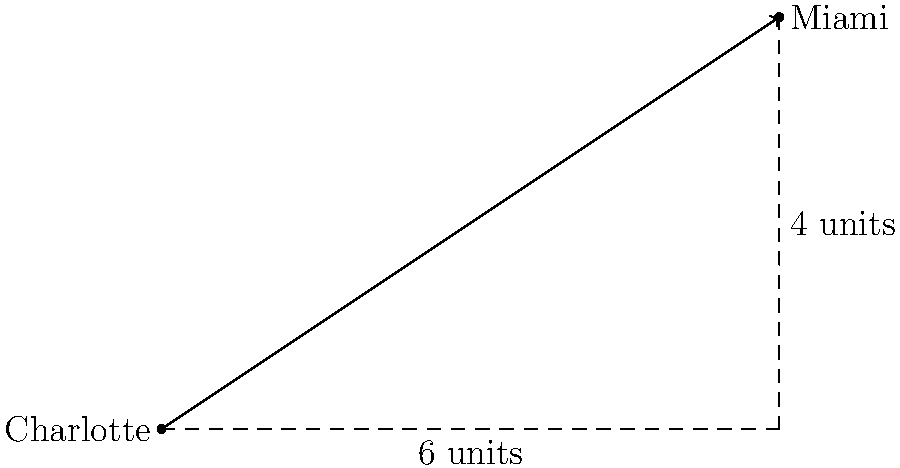As a proud North Carolinian and NBA enthusiast, you're planning a road trip to watch the Charlotte Hornets play an away game against the Miami Heat. On your map, Charlotte is represented at the origin (0,0), and Miami is located 6 units east and 4 units north. Using vector calculations, determine the direct distance between these two NBA cities. Let's approach this step-by-step using our God-given common sense and some basic math:

1) First, we need to understand that the vector from Charlotte to Miami can be represented as $\vec{v} = (6, 4)$.

2) To find the distance, we need to calculate the magnitude (length) of this vector.

3) The magnitude of a vector $(a, b)$ is given by the formula: $\sqrt{a^2 + b^2}$

4) Plugging in our values:
   
   $\text{Distance} = \sqrt{6^2 + 4^2}$

5) Let's calculate:
   
   $\text{Distance} = \sqrt{36 + 16} = \sqrt{52}$

6) Simplify:
   
   $\text{Distance} = 2\sqrt{13}$ units

Remember, this is a straight-line distance, not driving distance. Always plan your trips responsibly!
Answer: $2\sqrt{13}$ units 